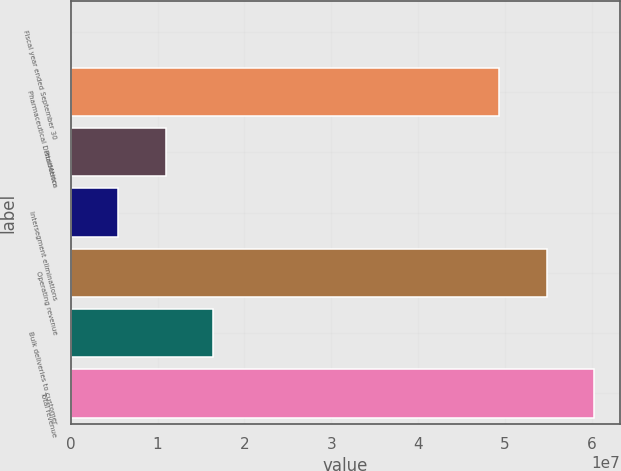Convert chart. <chart><loc_0><loc_0><loc_500><loc_500><bar_chart><fcel>Fiscal year ended September 30<fcel>Pharmaceutical Distribution<fcel>PharMerica<fcel>Intersegment eliminations<fcel>Operating revenue<fcel>Bulk deliveries to customer<fcel>Total revenue<nl><fcel>2005<fcel>4.93194e+07<fcel>1.09171e+07<fcel>5.45954e+06<fcel>5.47769e+07<fcel>1.63746e+07<fcel>6.02344e+07<nl></chart> 